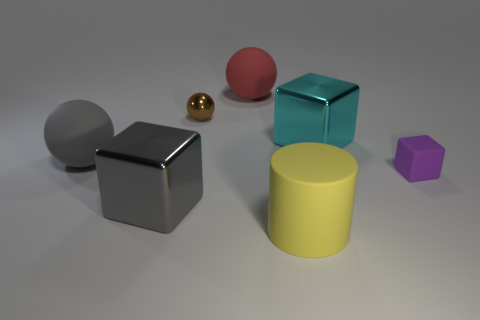Do the large metal thing that is in front of the gray sphere and the big ball in front of the large cyan metallic object have the same color?
Provide a short and direct response. Yes. Is the number of tiny purple rubber things that are to the left of the yellow rubber cylinder less than the number of brown shiny things that are in front of the tiny brown ball?
Make the answer very short. No. There is a rubber sphere behind the cyan metallic thing; is it the same size as the gray rubber ball?
Ensure brevity in your answer.  Yes. What shape is the big object that is behind the cyan metal thing?
Make the answer very short. Sphere. Is the number of big gray objects greater than the number of cyan metal objects?
Your answer should be very brief. Yes. What number of things are either large spheres right of the small metal sphere or large objects on the left side of the brown thing?
Your answer should be very brief. 3. What number of matte things are both to the left of the brown ball and in front of the gray cube?
Your response must be concise. 0. Do the brown sphere and the gray sphere have the same material?
Offer a terse response. No. There is a matte thing in front of the tiny thing that is in front of the ball that is left of the small brown sphere; what shape is it?
Your answer should be very brief. Cylinder. There is a big thing that is both to the right of the large gray metal object and to the left of the yellow matte object; what material is it made of?
Provide a short and direct response. Rubber. 